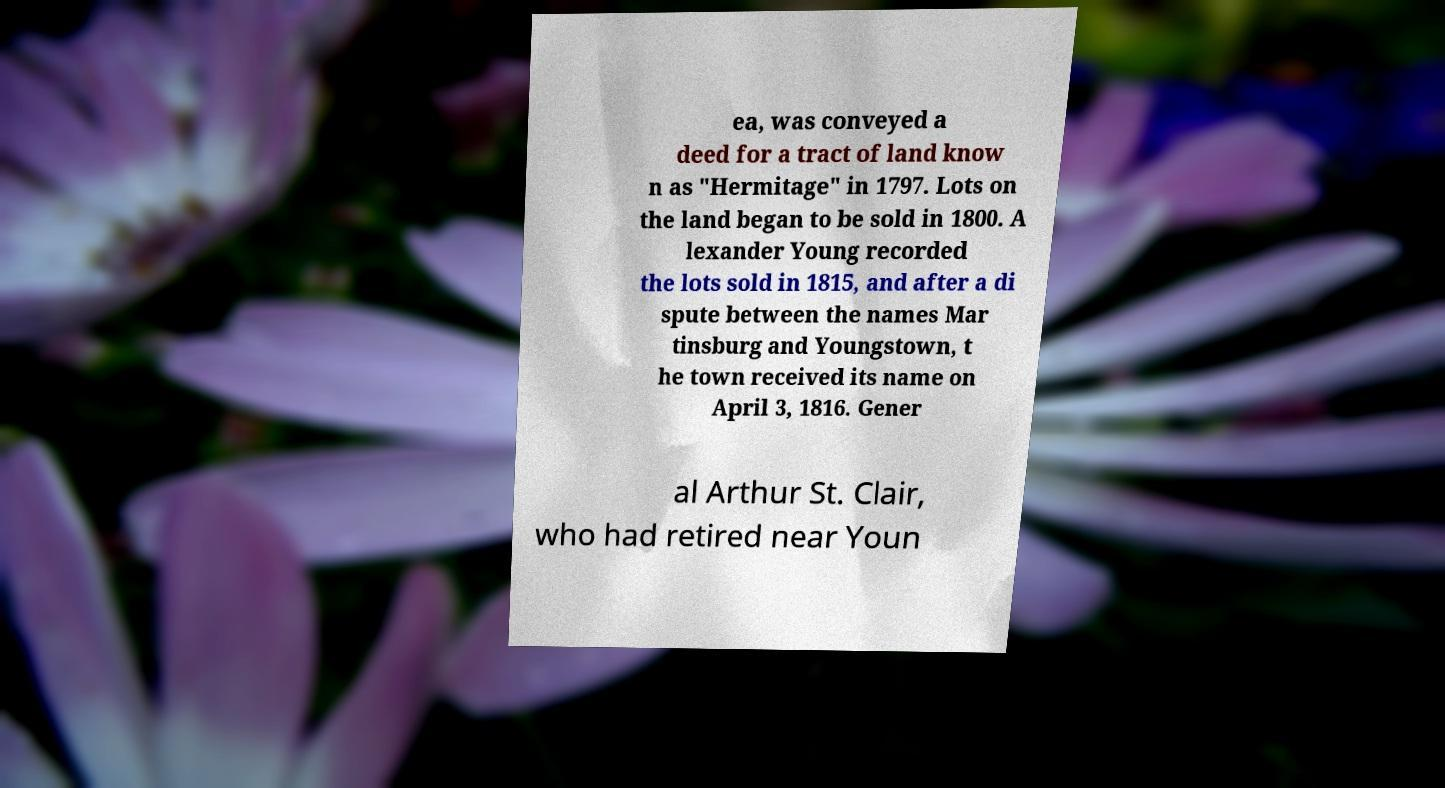I need the written content from this picture converted into text. Can you do that? ea, was conveyed a deed for a tract of land know n as "Hermitage" in 1797. Lots on the land began to be sold in 1800. A lexander Young recorded the lots sold in 1815, and after a di spute between the names Mar tinsburg and Youngstown, t he town received its name on April 3, 1816. Gener al Arthur St. Clair, who had retired near Youn 